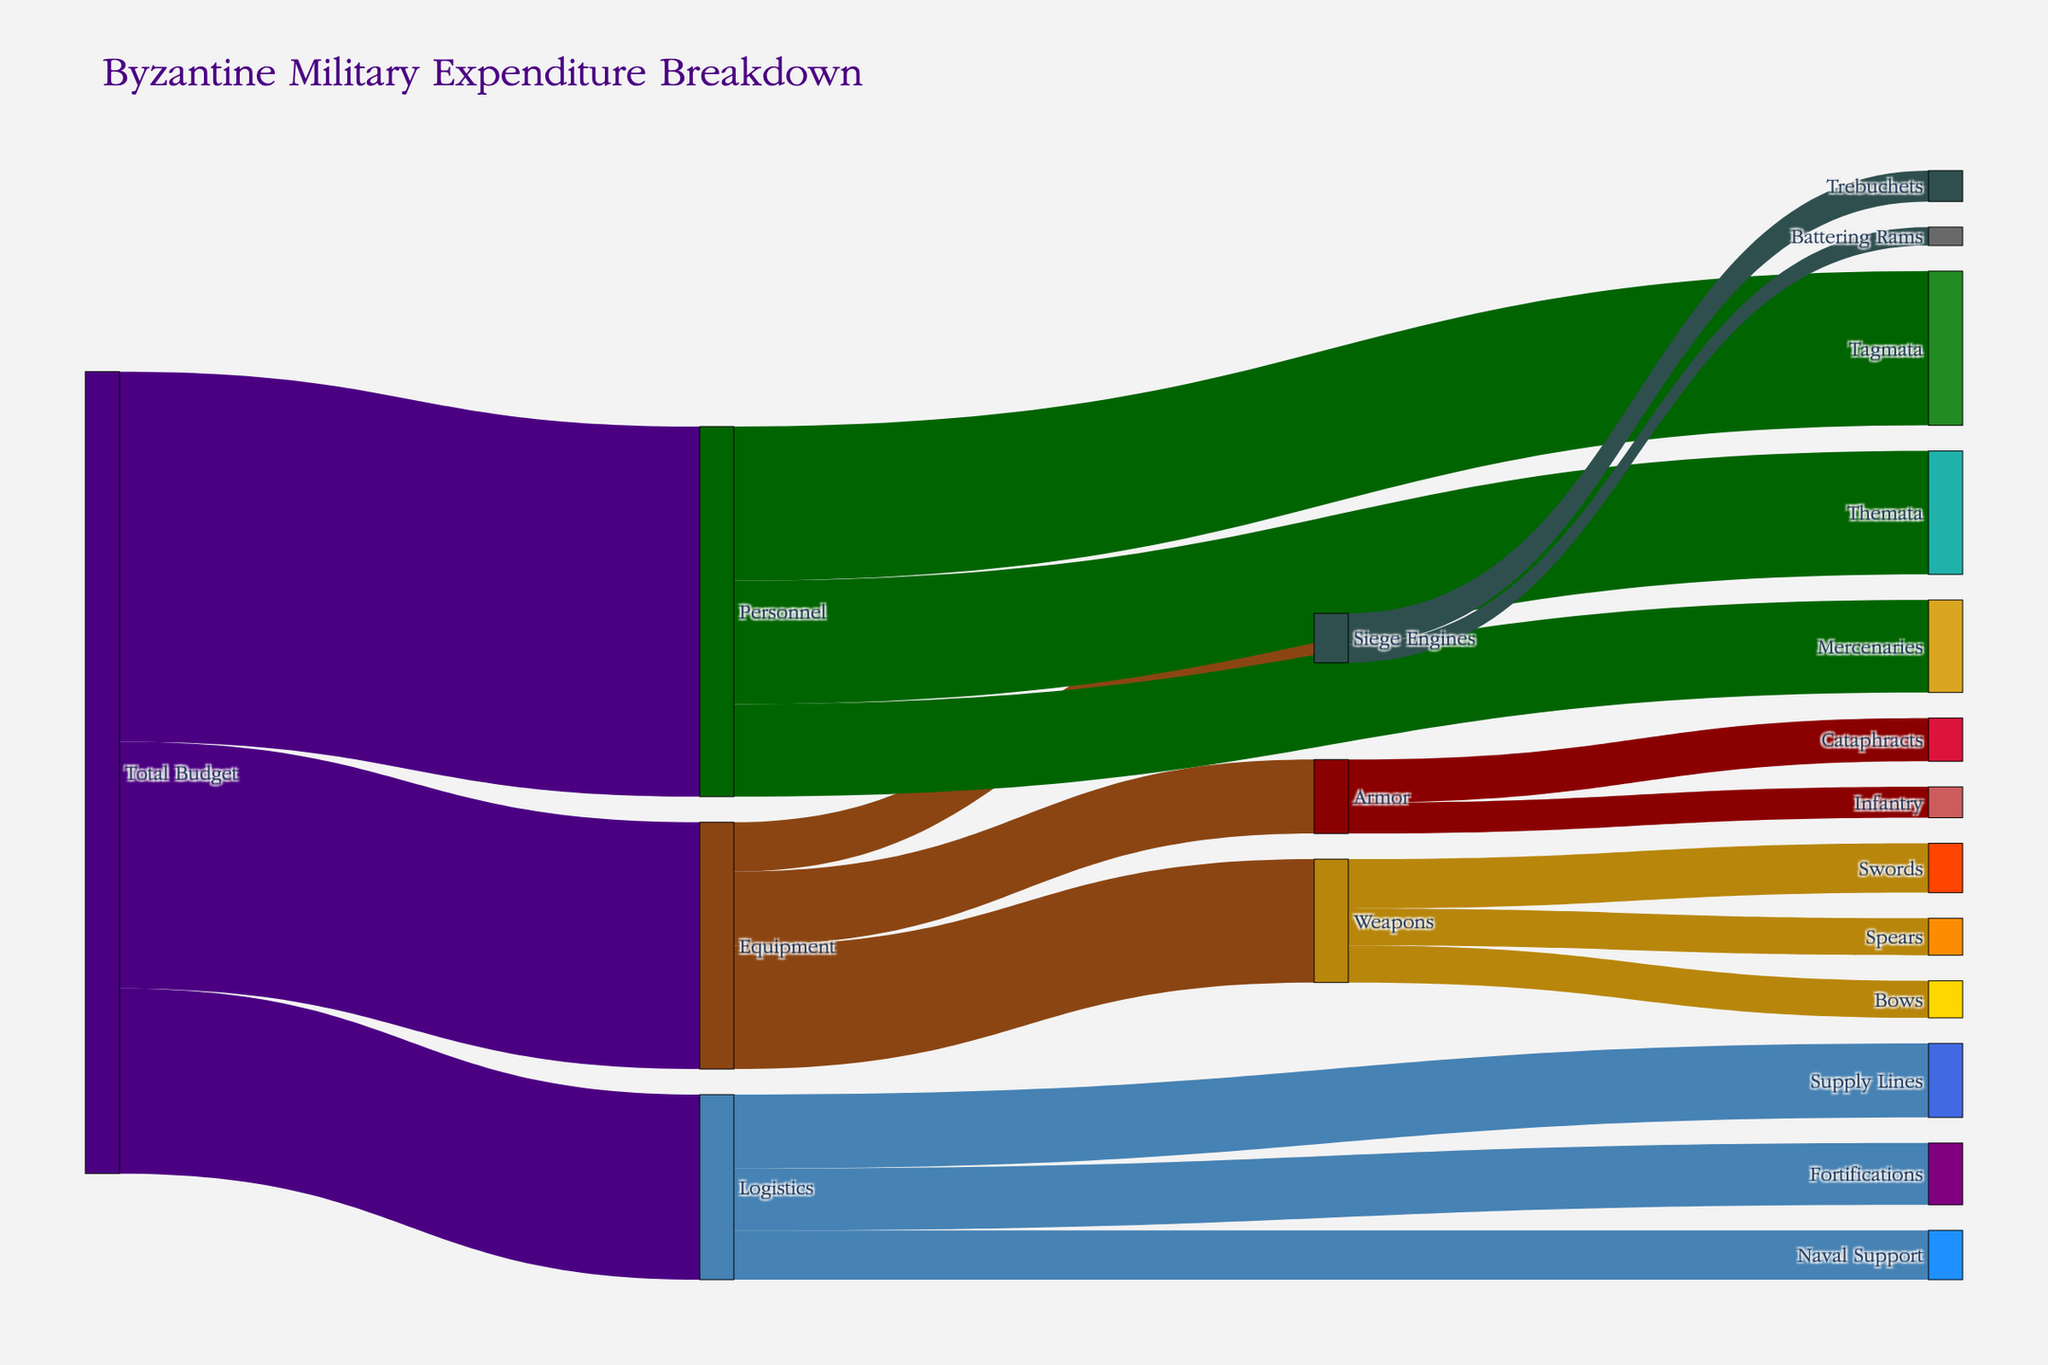What is the title of the figure? The title is displayed at the top of the figure, and it reads "Byzantine Military Expenditure Breakdown."
Answer: Byzantine Military Expenditure Breakdown What are the three main categories of Byzantine military expenditure? The Sankey Diagram shows that the main categories are the initial branches emerging from "Total Budget," which are "Equipment," "Personnel," and "Logistics."
Answer: Equipment, Personnel, Logistics Which category receives the largest portion of the budget? By looking at the figure, the width of the branch flowing from "Total Budget" to "Personnel" is the largest, indicating it receives the largest portion.
Answer: Personnel What is the total expenditure on Equipment? Summing up the values that flow from "Total Budget" to "Equipment" and within Equipment to sub-categories (Weapons, Armor, Siege Engines) gives: 2000000 + 1200000 + 800000 = 4000000
Answer: 4000000 How much of the Logistics budget is allocated to Naval Support? The corresponding branch from "Logistics" to "Naval Support" shows a value of 800000.
Answer: 800000 What percentage of the "Weapons" budget is spent on "Spears"? The total Weapons budget is the sum of Swords, Spears, and Bows: 800000 + 600000 + 600000 = 2000000. The budget for Spears is 600000. The percentage is (600000 / 2000000) * 100 = 30%.
Answer: 30% What is the difference in expenditure between Tagmata and Mercenaries? Tagmata has an expenditure value of 2500000, and Mercenaries have 1500000. The difference is 2500000 - 1500000 = 1000000.
Answer: 1000000 Which is more expensive: Siege Engines or Armor? Summing the values for Siege Engines (500000 + 300000 = 800000) and Armor (700000 + 500000 = 1200000), Armor is more expensive.
Answer: Armor Out of Swords, Spears, and Bows, which has the smallest budget allocation? By comparing the values for Swords (800000), Spears (600000), and Bows (600000), Spears and Bows have the smallest, both with 600000.
Answer: Spears and Bows How much is spent on Themata compared to the Naval Support? The expenditure for Themata is 2000000, and Naval Support is 800000. Themata has a higher expenditure.
Answer: Themata 